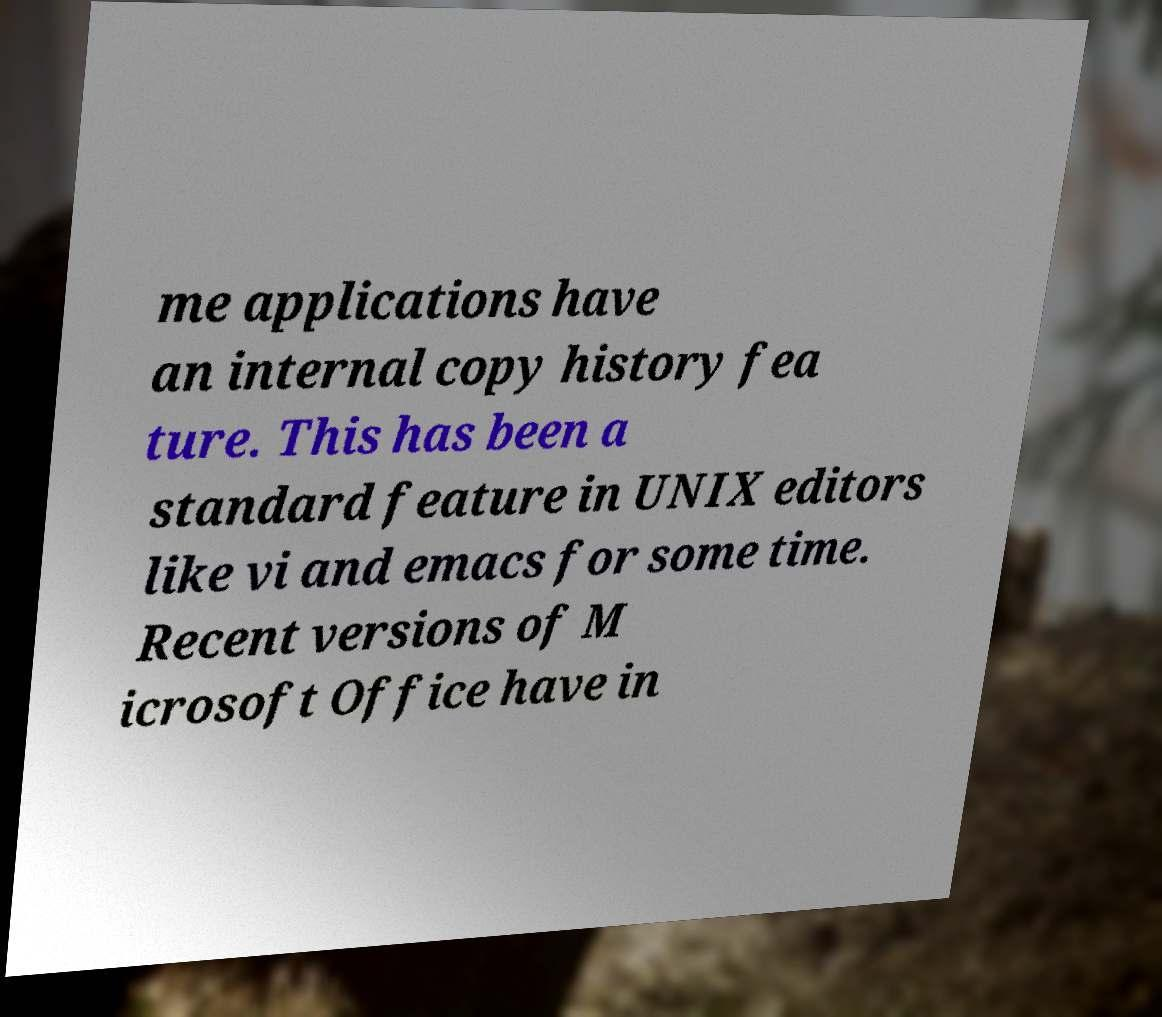Could you assist in decoding the text presented in this image and type it out clearly? me applications have an internal copy history fea ture. This has been a standard feature in UNIX editors like vi and emacs for some time. Recent versions of M icrosoft Office have in 